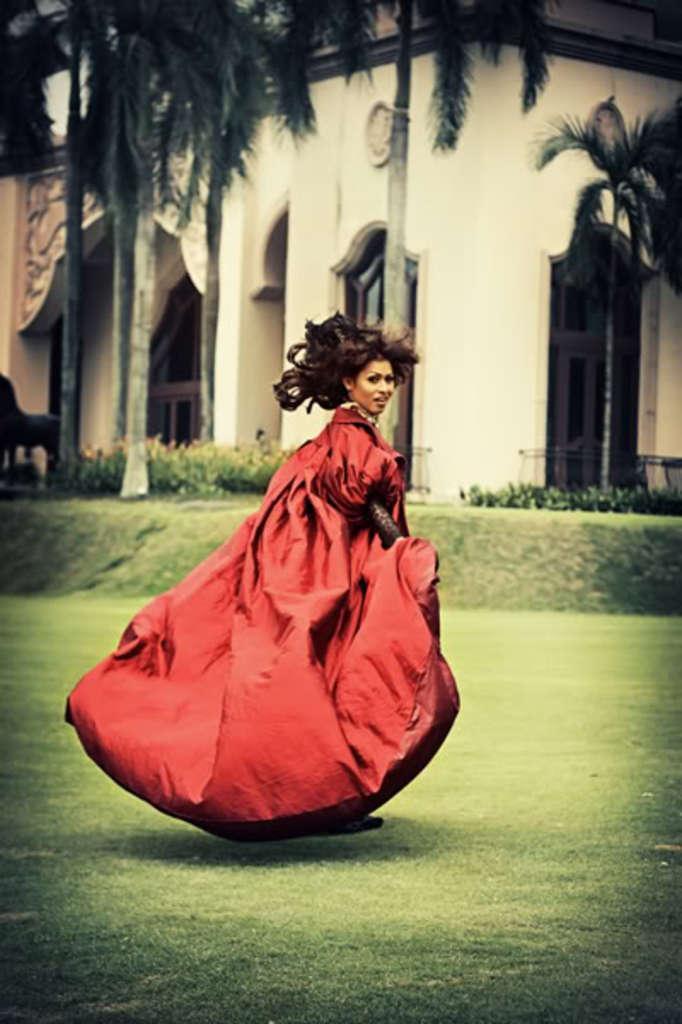In one or two sentences, can you explain what this image depicts? In this picture we can see a woman standing here, at the bottom there is grass, we can see a building in the background, on the left side there are some trees, we can see some plants here, this woman wore a red color dress. 